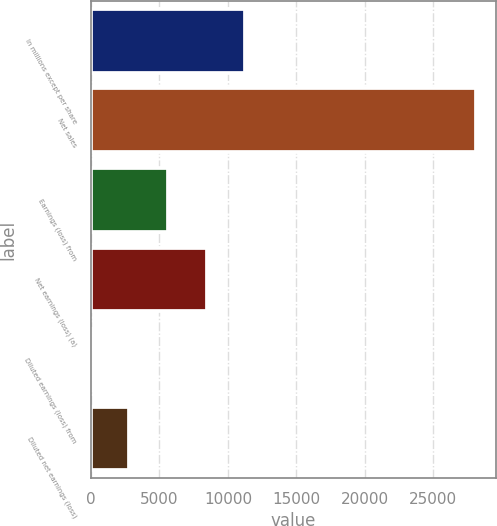<chart> <loc_0><loc_0><loc_500><loc_500><bar_chart><fcel>In millions except per share<fcel>Net sales<fcel>Earnings (loss) from<fcel>Net earnings (loss) (a)<fcel>Diluted earnings (loss) from<fcel>Diluted net earnings (loss)<nl><fcel>11251.1<fcel>28125<fcel>5626.46<fcel>8438.78<fcel>1.82<fcel>2814.14<nl></chart> 